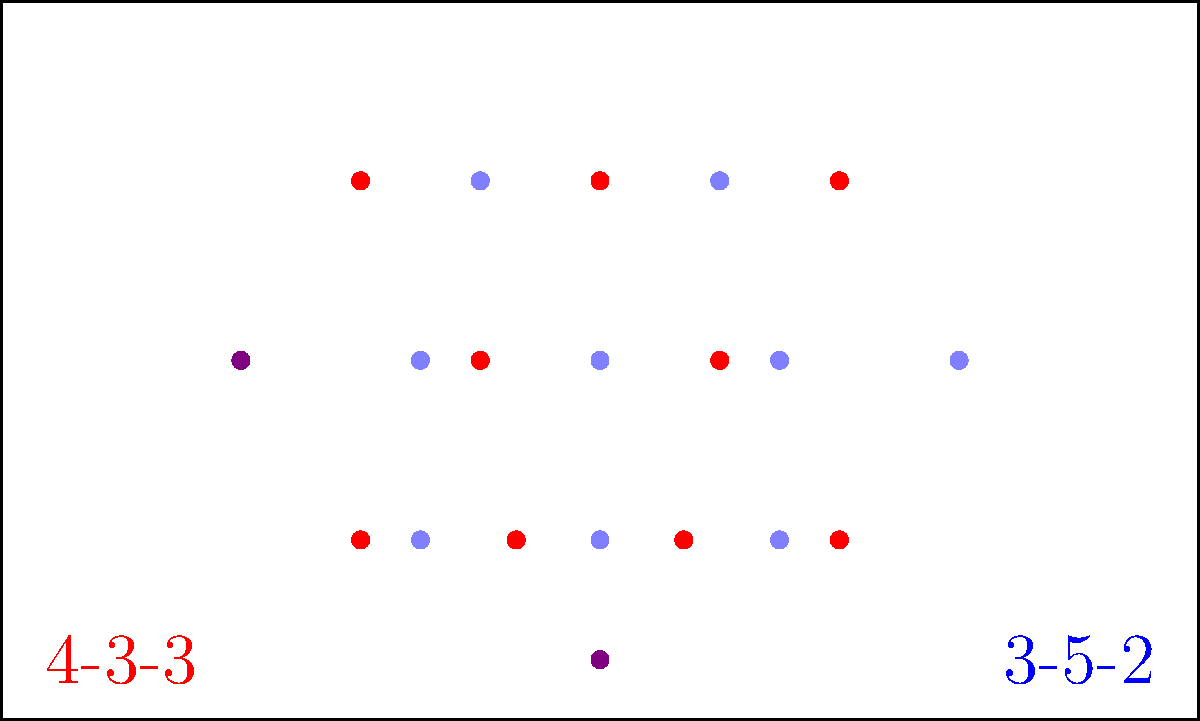Analyze the tactical implications of transitioning from a 4-3-3 formation (red) to a 3-5-2 formation (blue) in a women's football match. How might this change affect the team's defensive structure, midfield control, and attacking potential? Consider the strengths and weaknesses of each formation in the context of the Turkish Women's Super League. To analyze the transition from a 4-3-3 to a 3-5-2 formation, we need to consider several factors:

1. Defensive structure:
   - 4-3-3: Four defenders provide a solid backline with two center-backs and two full-backs.
   - 3-5-2: Three center-backs form the defensive core, potentially vulnerable to wide attacks.

2. Midfield control:
   - 4-3-3: Three midfielders (typically one defensive and two box-to-box) offer balance.
   - 3-5-2: Five midfielders provide increased presence in the center, with wing-backs offering width.

3. Attacking potential:
   - 4-3-3: Three forwards allow for a central striker and two wide attackers.
   - 3-5-2: Two strikers up front with support from advancing midfielders.

4. Turkish Women's Super League context:
   - Consider the league's playing style, common formations, and individual team strengths.

5. Transition implications:
   - Defensive: Losing one defender requires midfielders to track back more.
   - Midfield: Gain in numbers allows for better possession and pressing.
   - Attack: Loss of wide forwards but potential for more central penetration.

6. Player roles:
   - Full-backs in 4-3-3 may become wing-backs or wide midfielders in 3-5-2.
   - One center-back may move to a defensive midfield role.
   - Wide forwards may need to adapt to central striking positions or midfield roles.

7. Tactical flexibility:
   - 3-5-2 can easily transition to 5-3-2 for defensive situations.
   - Allows for quick counterattacks with two strikers always forward.

8. Potential weaknesses:
   - 3-5-2 may struggle against teams with fast, wide attackers.
   - Requires high fitness levels from wing-backs to cover entire flank.

9. Strengths:
   - Increased midfield presence can help dominate possession.
   - Two strikers can put more pressure on opposing defenders.

The effectiveness of this transition depends on the team's personnel, opponent's tactics, and ability to adapt to new roles.
Answer: Transition to 3-5-2 increases midfield control and central attacking options but may leave flanks vulnerable; success depends on player adaptation and opponent's tactics. 